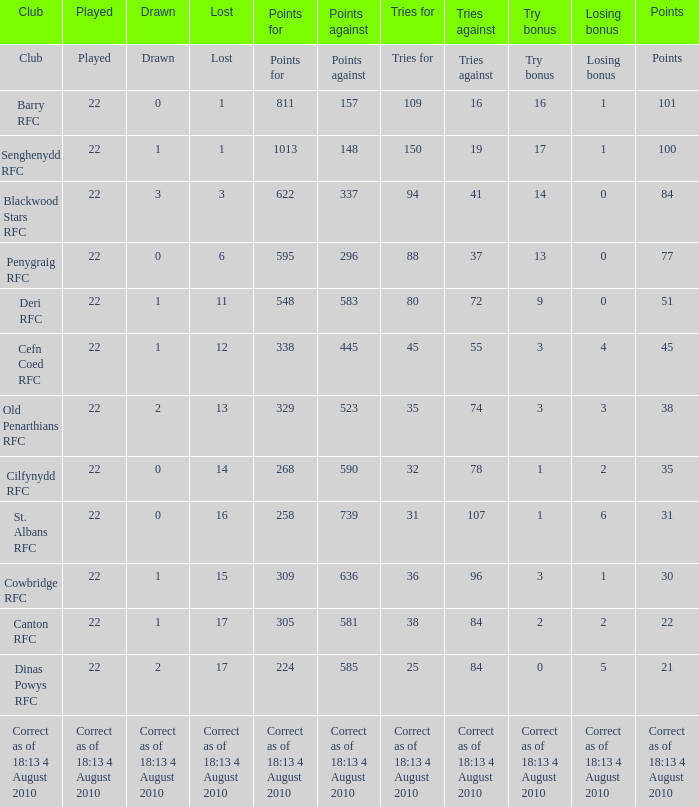What is the points when the lost was 11? 548.0. 